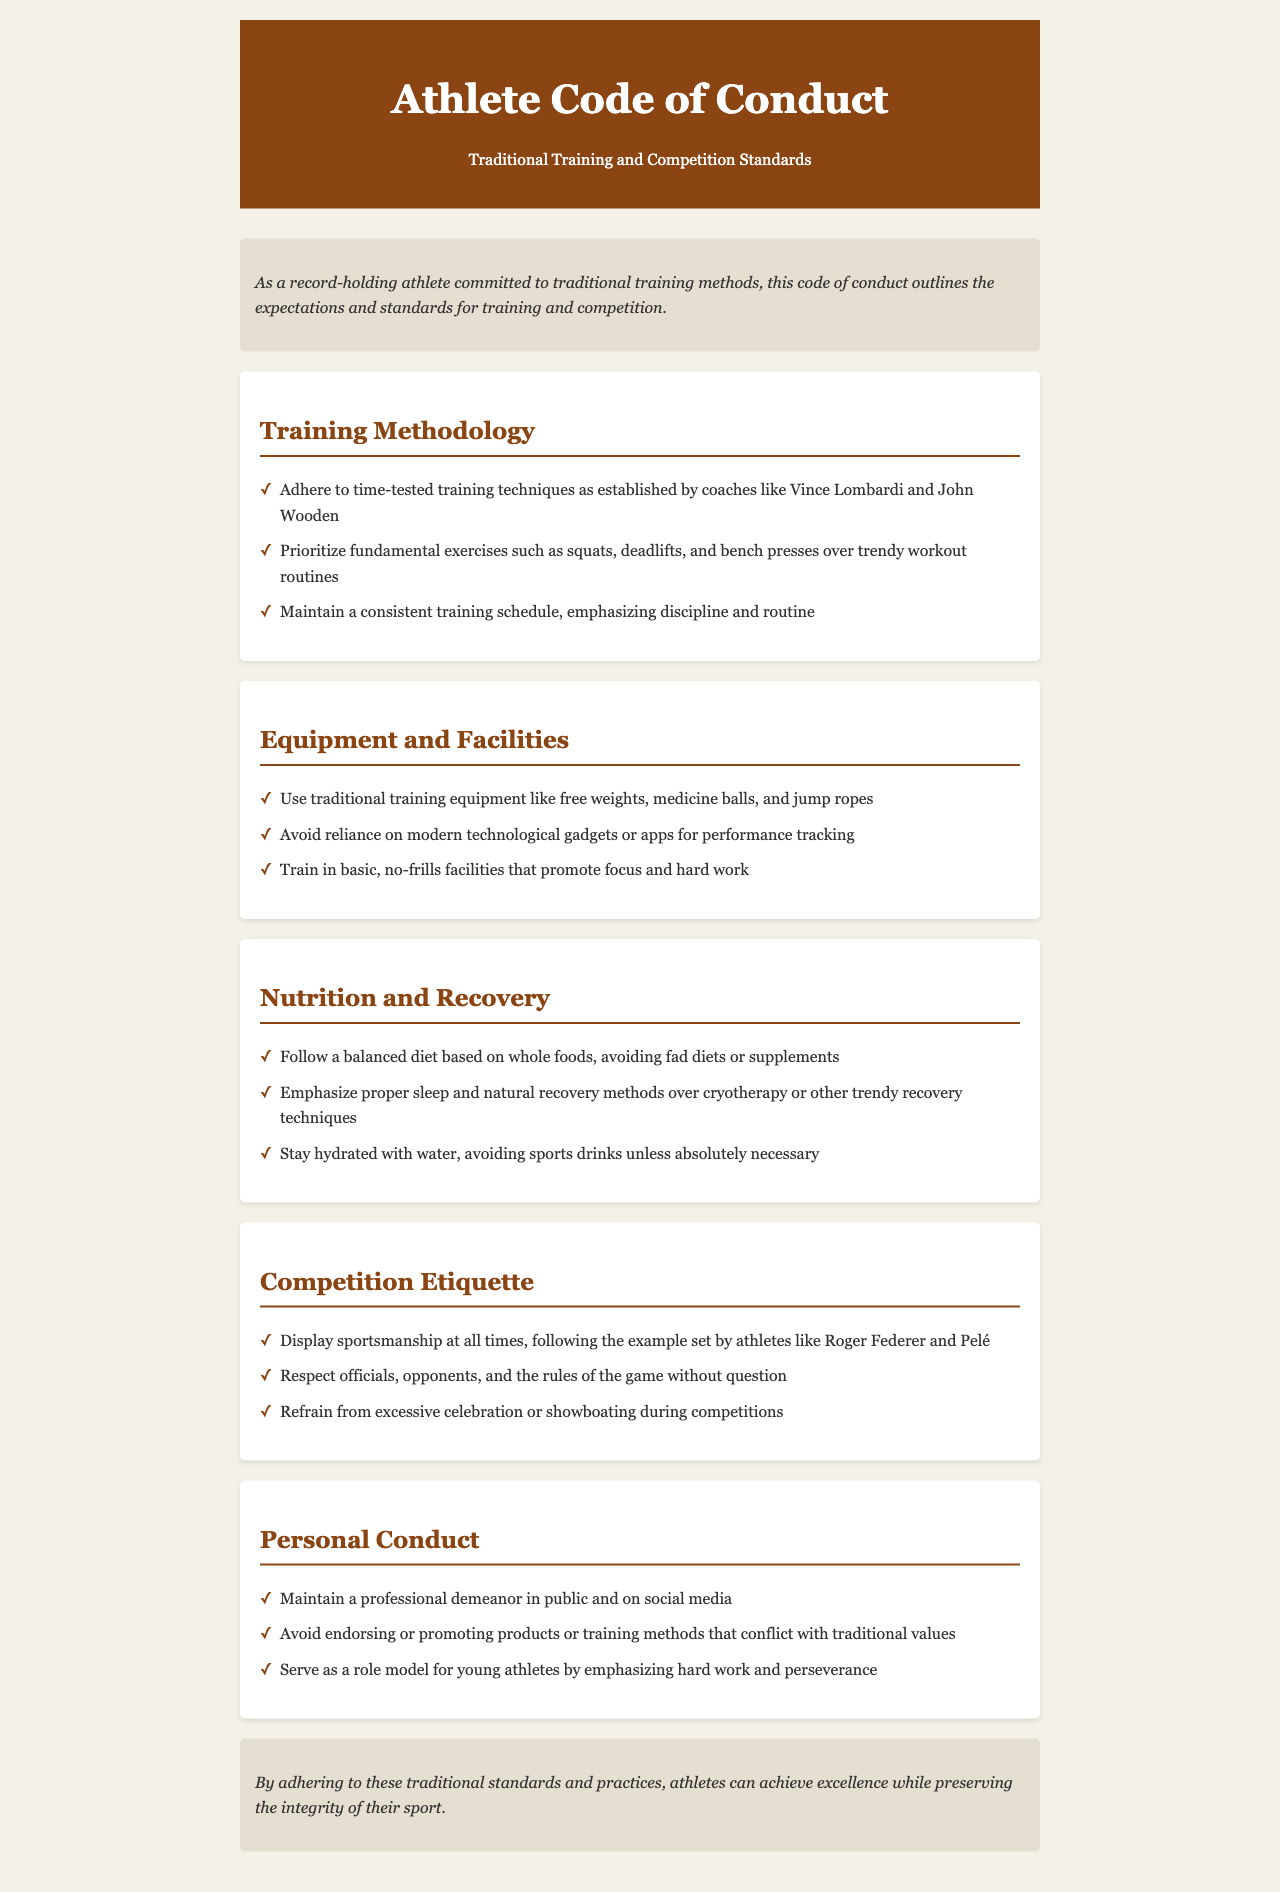What is the title of the document? The title is provided at the top of the document, stating the focus on athlete conduct and traditional training standards.
Answer: Athlete Code of Conduct: Traditional Training and Competition Standards Who are two coaches mentioned in the training methodology? The document lists coaches who exemplify the traditional training methods; specific names are provided.
Answer: Vince Lombardi and John Wooden What type of diet should an athlete follow according to the nutrition and recovery section? The document emphasizes a dietary approach that focuses on whole foods instead of modern trends.
Answer: Balanced diet based on whole foods What is emphasized over trendy workout routines? The document highlights a specific approach to exercise that is consistent with traditional values.
Answer: Fundamental exercises What should athletes avoid in terms of modern tools? The section on equipment and facilities instructs athletes on what modern supports should not be used.
Answer: Modern technological gadgets or apps How should athletes conduct themselves in public? The personal conduct section sets expectations for athlete behavior in various contexts.
Answer: Maintain a professional demeanor What is a recommended traditional recovery method? The document suggests a particular kind of recovery over newer techniques.
Answer: Natural recovery methods What attitude should athletes display towards officials? The competition etiquette section defines the interaction expected between athletes and officials.
Answer: Respect 